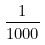<formula> <loc_0><loc_0><loc_500><loc_500>\frac { 1 } { 1 0 0 0 }</formula> 